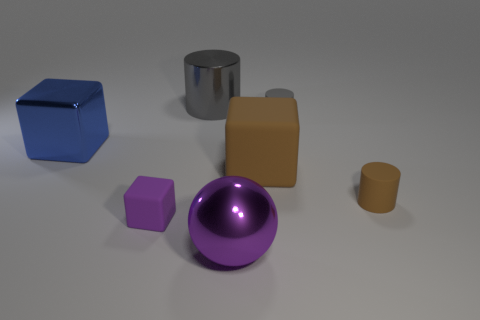Add 1 big gray things. How many objects exist? 8 Subtract all small rubber cylinders. How many cylinders are left? 1 Subtract 1 cylinders. How many cylinders are left? 2 Subtract all brown cylinders. How many cylinders are left? 2 Subtract all blue blocks. How many brown cylinders are left? 1 Subtract all purple cubes. Subtract all cyan spheres. How many cubes are left? 2 Add 1 gray rubber cylinders. How many gray rubber cylinders are left? 2 Add 3 large green metallic cylinders. How many large green metallic cylinders exist? 3 Subtract 1 blue cubes. How many objects are left? 6 Subtract all cylinders. How many objects are left? 4 